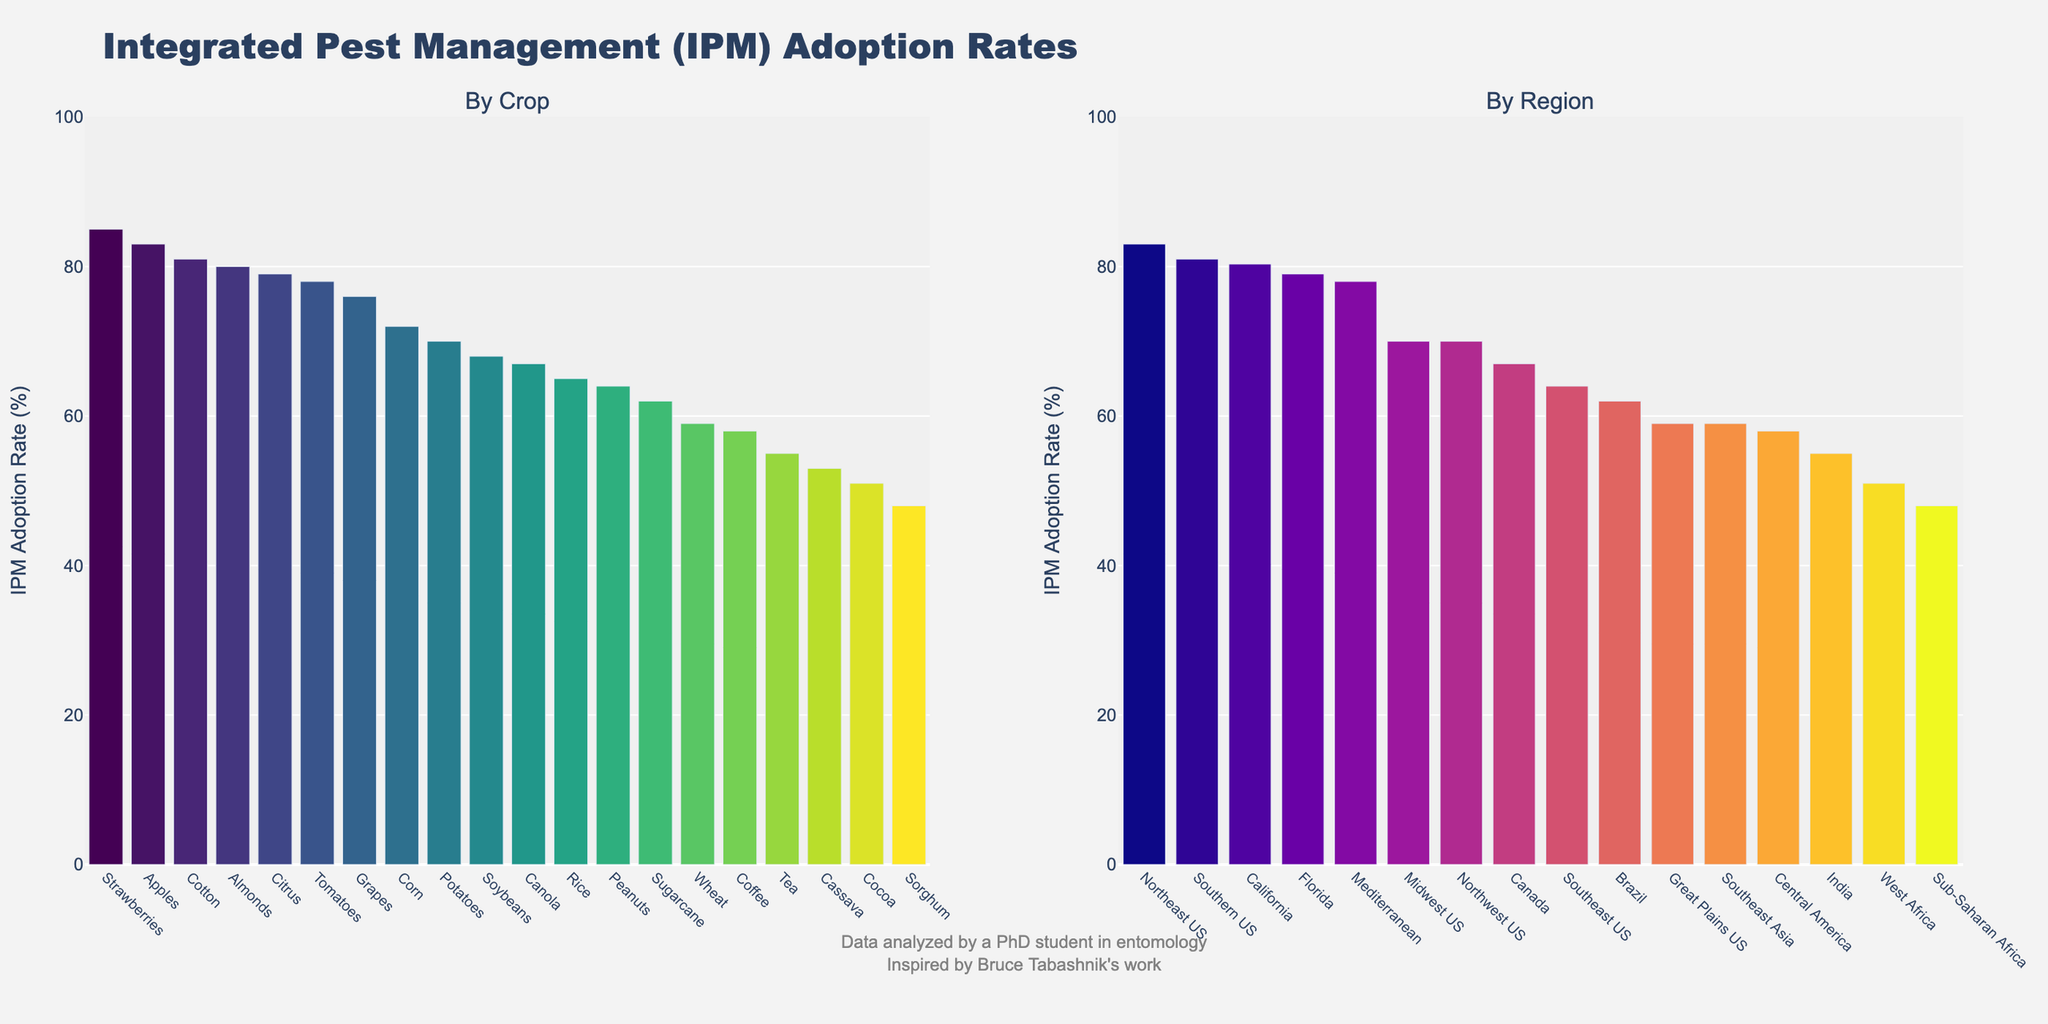Which crop has the highest IPM adoption rate? Look at the first bar in the "By Crop" section. The tallest bar corresponds to Strawberries with an adoption rate of 85%.
Answer: Strawberries Which region has the lowest average IPM adoption rate? Refer to the "By Region" section. The shortest bar represents Sub-Saharan Africa with an average IPM adoption rate of 48%.
Answer: Sub-Saharan Africa What is the difference in IPM adoption rate between Almonds and Cassava? Almonds have a rate of 80%, and Cassava has a rate of 53%. Calculate the difference: 80 - 53 = 27.
Answer: 27% Which region has a higher average IPM adoption rate, Florida or Southeast Asia? From the "By Region" section, identify Florida and Southeast Asia. Florida has a rate of 79%, and Southeast Asia has 59% (average of Rice and Cassava's rates). Florida's rate is higher.
Answer: Florida What's the average IPM adoption rate for crops grown in California? California has Grapes (76%), Strawberries (85%), and Almonds (80%). Calculate the average: (76 + 85 + 80) / 3 = 80.3.
Answer: 80.3% Which crop has more than 70% but less than 80% IPM adoption rate? Scan the "By Crop" section for bars within the 70%-80% range. Grapes, Corn, and Potatoes fit this criterion with 76%, 72%, and 70%, respectively.
Answer: Grapes, Corn, Potatoes What is the combined IPM adoption rate for Coffee and Cocoa? Coffee has an IPM rate of 58%, and Cocoa has 51%. Add the rates: 58 + 51 = 109%.
Answer: 109% Compare the IPM adoption rates of Rice and Peanuts. Which crop has a higher rate and by how much? Rice has a rate of 65% and Peanuts 64%. Calculate the difference: 65 - 64 = 1. Rice has a higher rate by 1%.
Answer: Rice by 1% What is the median IPM adoption rate of all crops? List the rates in order: 48, 51, 53, 55, 58, 59, 62, 64, 65, 67, 68, 70, 72, 76, 78, 79, 80, 81, 83, 85. The median is the middle value: 68.5.
Answer: 68.5% How does the IPM adoption rate of Cotton compare to that of Soybeans? Cotton has an IPM rate of 81%, and Soybeans have a rate of 68%. Cotton's rate is higher.
Answer: Cotton is higher 